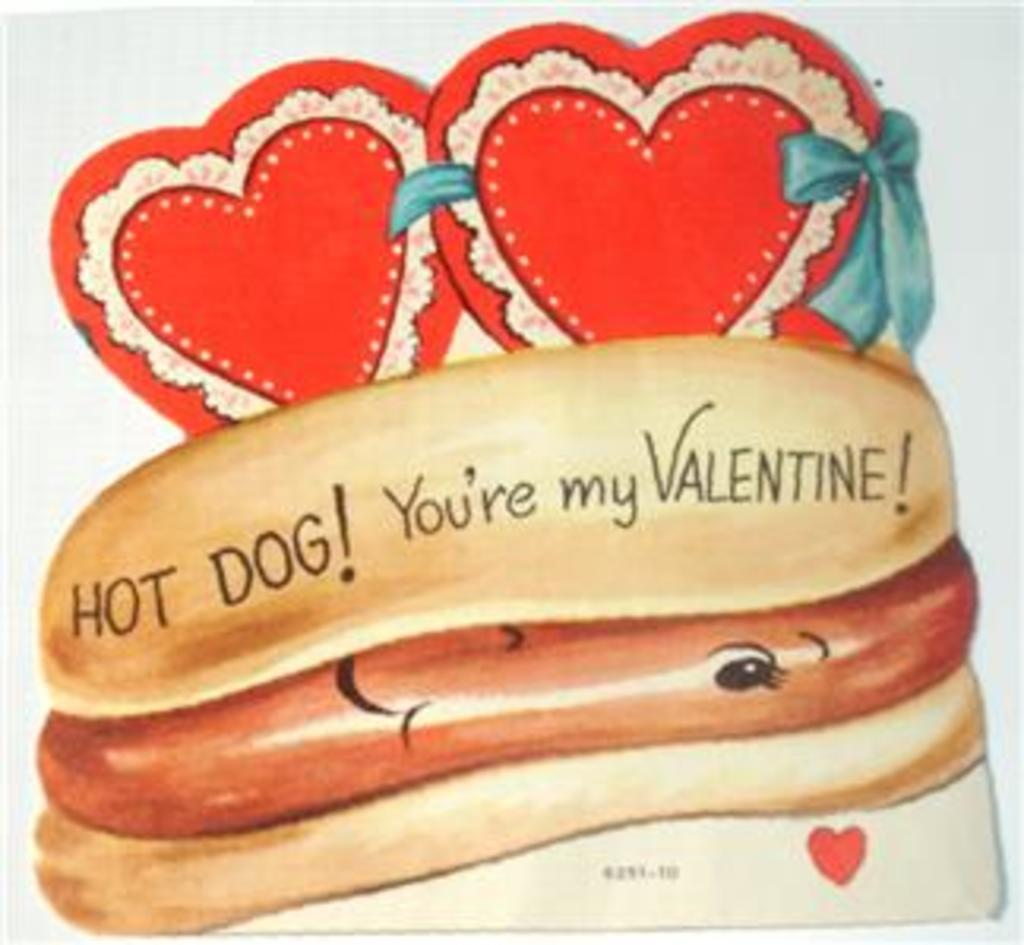What is present on the paper in the image? There is food depicted on the paper. Are there any additional elements on the paper besides the food? Yes, there are decorative objects on the paper. Can you see any cellars or feathers in the image? No, there are no cellars or feathers present in the image. Is there any baseball equipment visible in the image? No, there is no baseball equipment visible in the image. 